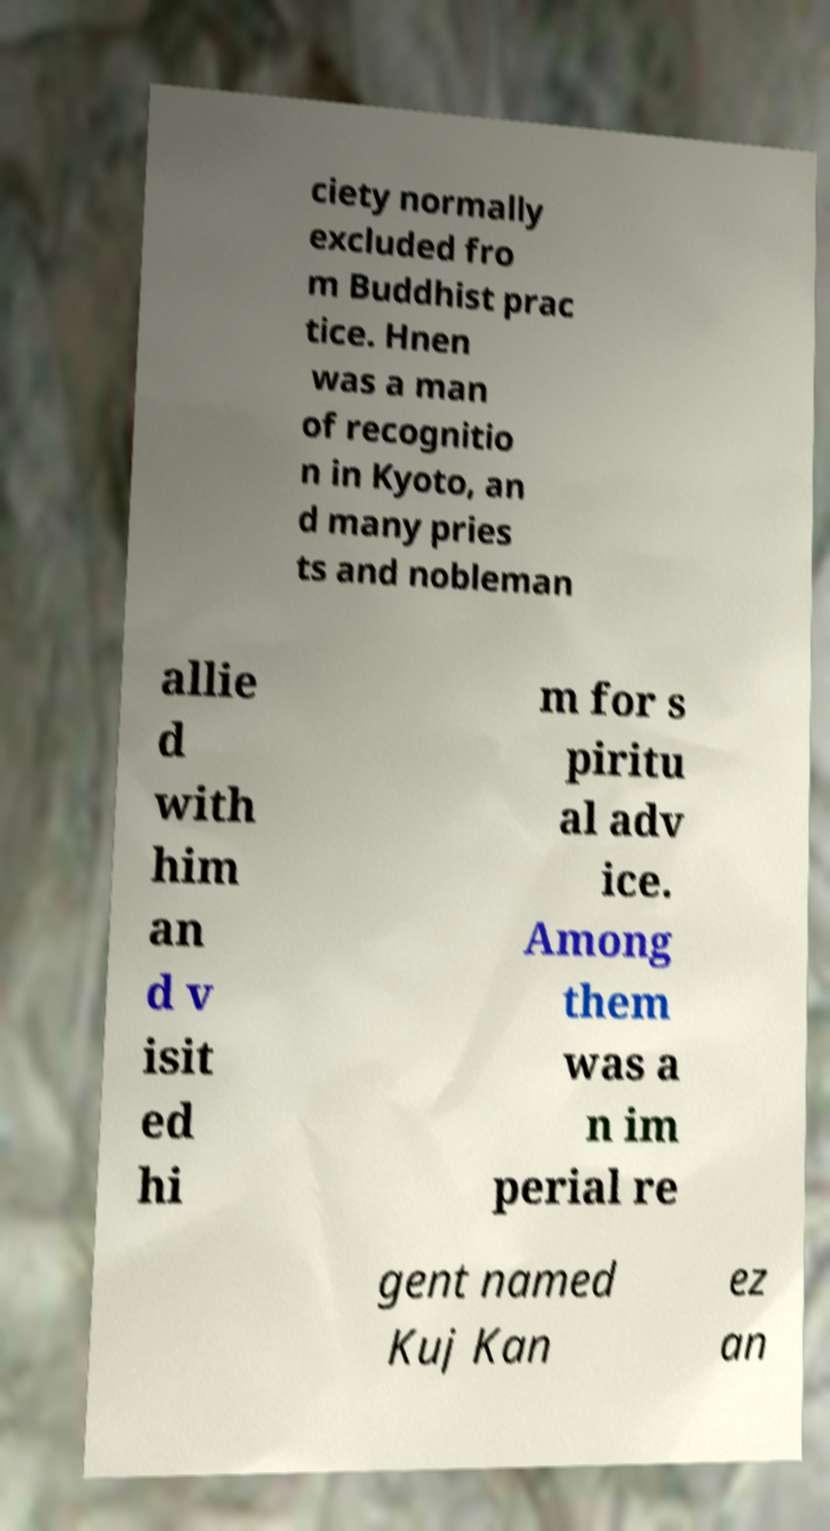Could you extract and type out the text from this image? ciety normally excluded fro m Buddhist prac tice. Hnen was a man of recognitio n in Kyoto, an d many pries ts and nobleman allie d with him an d v isit ed hi m for s piritu al adv ice. Among them was a n im perial re gent named Kuj Kan ez an 